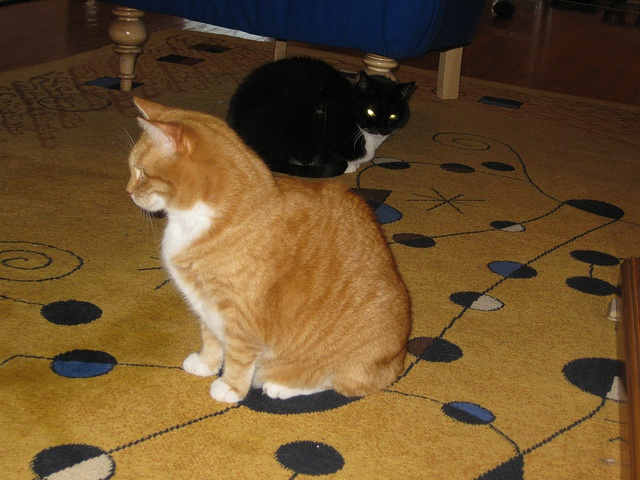Describe the objects in this image and their specific colors. I can see cat in black, olive, and tan tones and cat in black, gray, and darkgray tones in this image. 